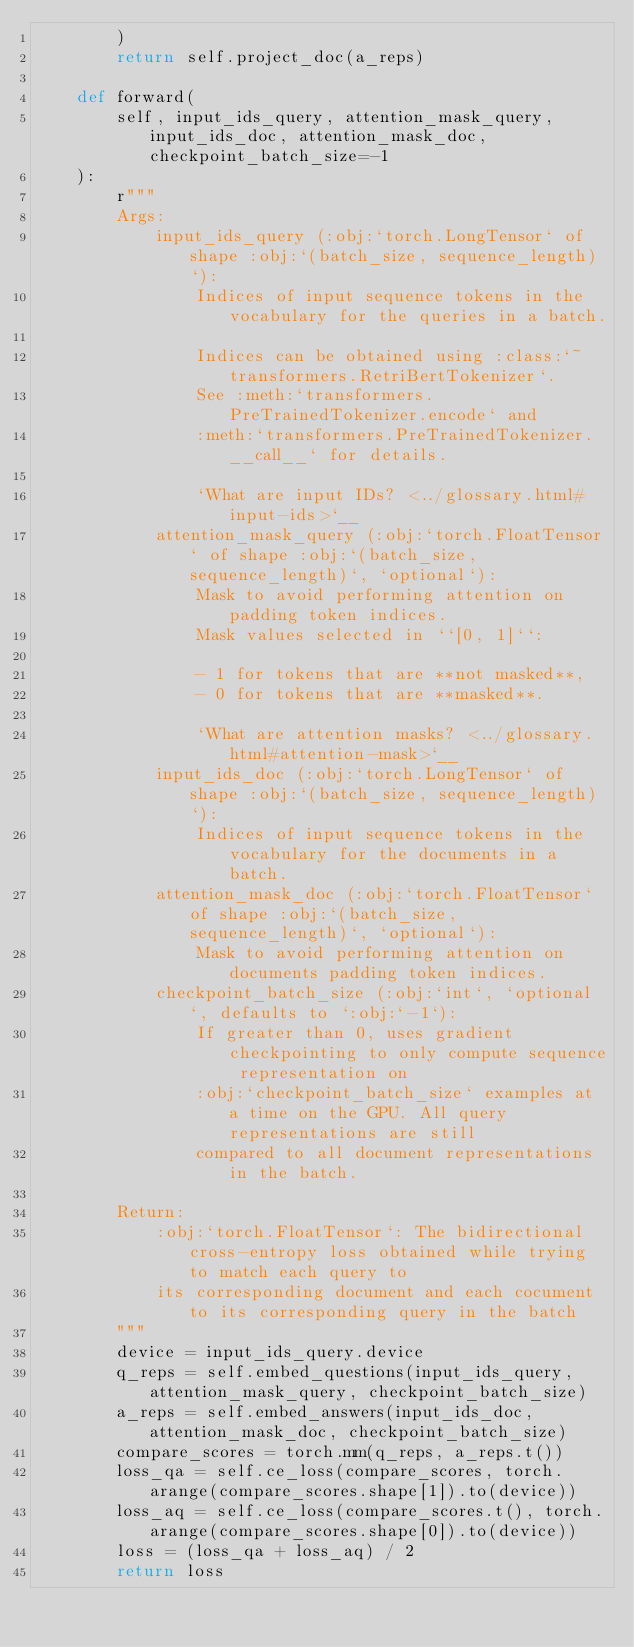Convert code to text. <code><loc_0><loc_0><loc_500><loc_500><_Python_>        )
        return self.project_doc(a_reps)

    def forward(
        self, input_ids_query, attention_mask_query, input_ids_doc, attention_mask_doc, checkpoint_batch_size=-1
    ):
        r"""
        Args:
            input_ids_query (:obj:`torch.LongTensor` of shape :obj:`(batch_size, sequence_length)`):
                Indices of input sequence tokens in the vocabulary for the queries in a batch.

                Indices can be obtained using :class:`~transformers.RetriBertTokenizer`.
                See :meth:`transformers.PreTrainedTokenizer.encode` and
                :meth:`transformers.PreTrainedTokenizer.__call__` for details.

                `What are input IDs? <../glossary.html#input-ids>`__
            attention_mask_query (:obj:`torch.FloatTensor` of shape :obj:`(batch_size, sequence_length)`, `optional`):
                Mask to avoid performing attention on padding token indices.
                Mask values selected in ``[0, 1]``:

                - 1 for tokens that are **not masked**,
                - 0 for tokens that are **masked**.

                `What are attention masks? <../glossary.html#attention-mask>`__
            input_ids_doc (:obj:`torch.LongTensor` of shape :obj:`(batch_size, sequence_length)`):
                Indices of input sequence tokens in the vocabulary for the documents in a batch.
            attention_mask_doc (:obj:`torch.FloatTensor` of shape :obj:`(batch_size, sequence_length)`, `optional`):
                Mask to avoid performing attention on documents padding token indices.
            checkpoint_batch_size (:obj:`int`, `optional`, defaults to `:obj:`-1`):
                If greater than 0, uses gradient checkpointing to only compute sequence representation on
                :obj:`checkpoint_batch_size` examples at a time on the GPU. All query representations are still
                compared to all document representations in the batch.

        Return:
            :obj:`torch.FloatTensor`: The bidirectional cross-entropy loss obtained while trying to match each query to
            its corresponding document and each cocument to its corresponding query in the batch
        """
        device = input_ids_query.device
        q_reps = self.embed_questions(input_ids_query, attention_mask_query, checkpoint_batch_size)
        a_reps = self.embed_answers(input_ids_doc, attention_mask_doc, checkpoint_batch_size)
        compare_scores = torch.mm(q_reps, a_reps.t())
        loss_qa = self.ce_loss(compare_scores, torch.arange(compare_scores.shape[1]).to(device))
        loss_aq = self.ce_loss(compare_scores.t(), torch.arange(compare_scores.shape[0]).to(device))
        loss = (loss_qa + loss_aq) / 2
        return loss
</code> 